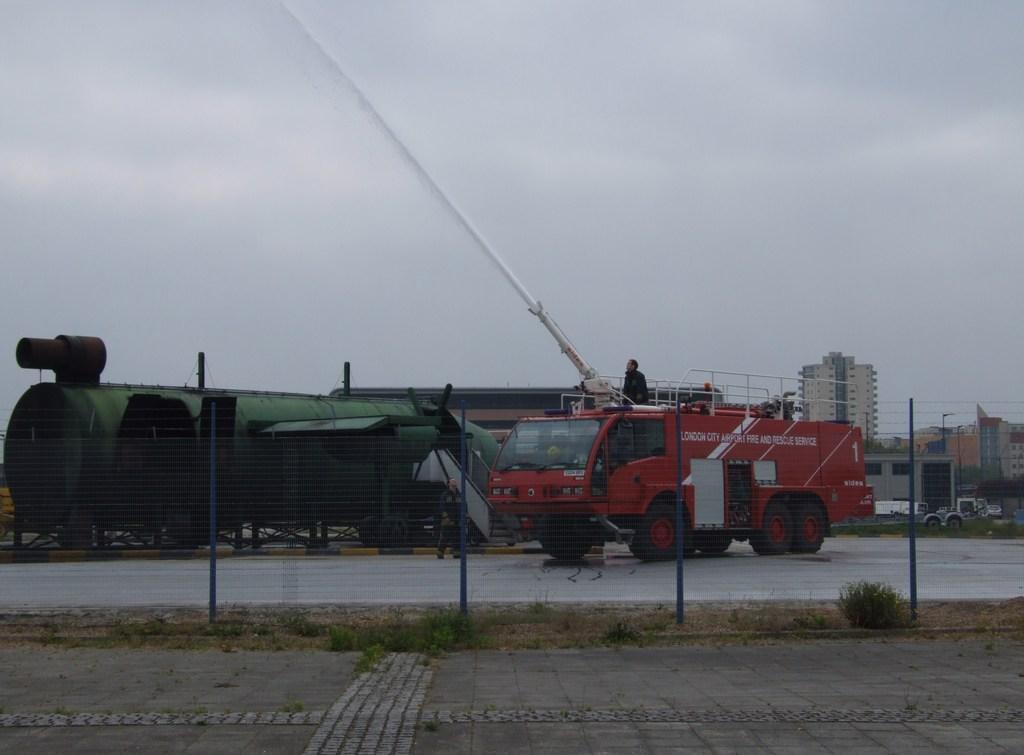Describe this image in one or two sentences. This image consists of a fire engine. At the bottom, there is a road. In the middle, there is a fencing. On the left, there is a tank. On the right, we can see the buildings. At the top, there is sky. 